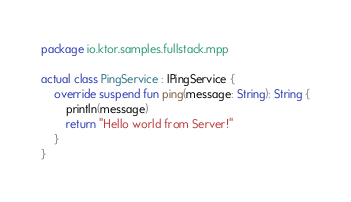<code> <loc_0><loc_0><loc_500><loc_500><_Kotlin_>package io.ktor.samples.fullstack.mpp

actual class PingService : IPingService {
    override suspend fun ping(message: String): String {
        println(message)
        return "Hello world from Server!"
    }
}
</code> 